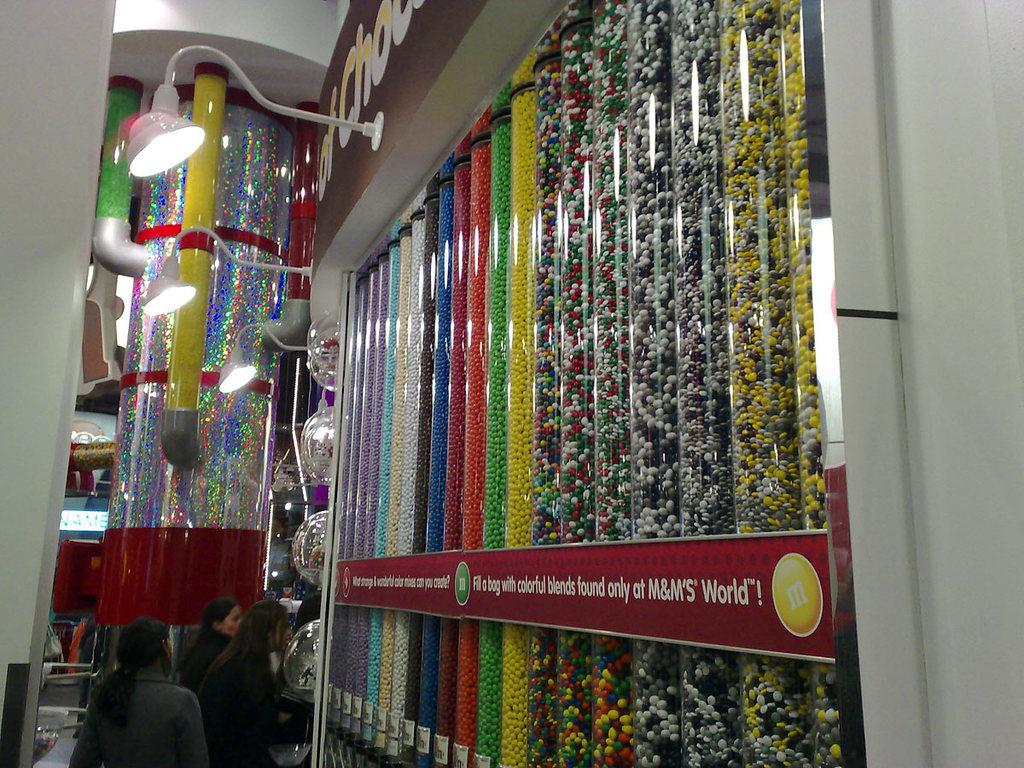<image>
Render a clear and concise summary of the photo. M logo for the candy m & m and a banner that says fill a bag with colorful blends found only at M&M 